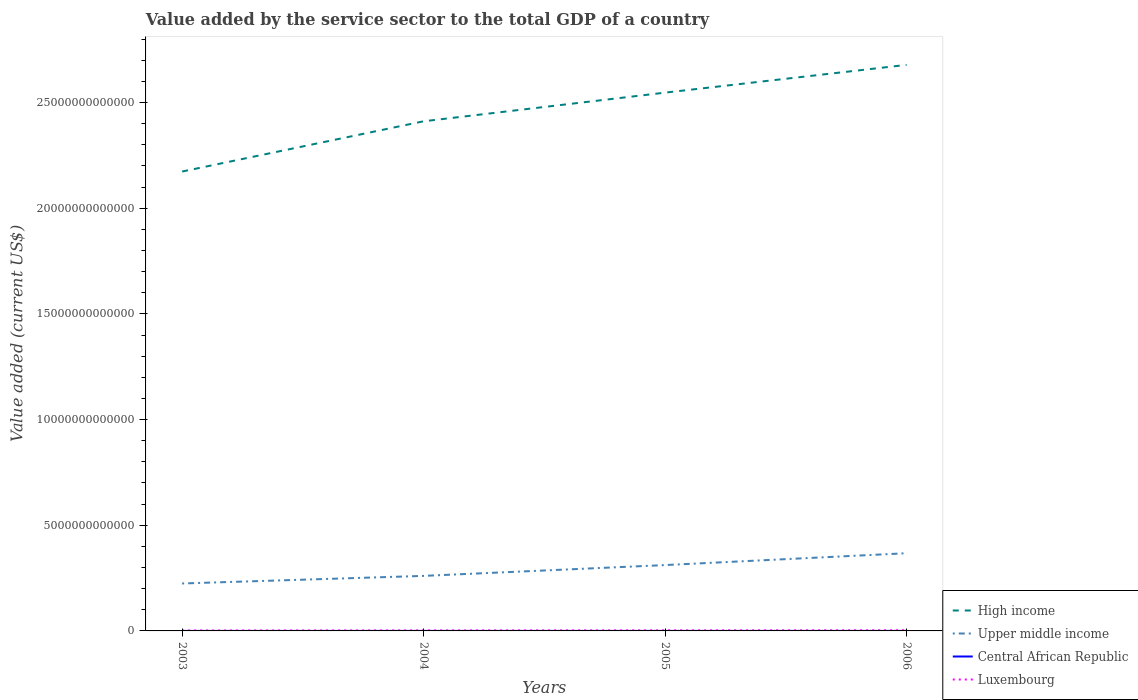How many different coloured lines are there?
Provide a short and direct response. 4. Does the line corresponding to Upper middle income intersect with the line corresponding to Central African Republic?
Offer a very short reply. No. Across all years, what is the maximum value added by the service sector to the total GDP in High income?
Ensure brevity in your answer.  2.17e+13. In which year was the value added by the service sector to the total GDP in Central African Republic maximum?
Keep it short and to the point. 2003. What is the total value added by the service sector to the total GDP in High income in the graph?
Your answer should be very brief. -2.67e+12. What is the difference between the highest and the second highest value added by the service sector to the total GDP in Upper middle income?
Make the answer very short. 1.43e+12. What is the difference between the highest and the lowest value added by the service sector to the total GDP in High income?
Offer a very short reply. 2. What is the difference between two consecutive major ticks on the Y-axis?
Your answer should be very brief. 5.00e+12. Does the graph contain any zero values?
Offer a terse response. No. Does the graph contain grids?
Your answer should be compact. No. How many legend labels are there?
Provide a short and direct response. 4. What is the title of the graph?
Give a very brief answer. Value added by the service sector to the total GDP of a country. Does "Tunisia" appear as one of the legend labels in the graph?
Your answer should be compact. No. What is the label or title of the Y-axis?
Keep it short and to the point. Value added (current US$). What is the Value added (current US$) of High income in 2003?
Provide a succinct answer. 2.17e+13. What is the Value added (current US$) of Upper middle income in 2003?
Provide a short and direct response. 2.24e+12. What is the Value added (current US$) of Central African Republic in 2003?
Provide a short and direct response. 3.19e+08. What is the Value added (current US$) of Luxembourg in 2003?
Provide a short and direct response. 2.13e+1. What is the Value added (current US$) of High income in 2004?
Provide a succinct answer. 2.41e+13. What is the Value added (current US$) in Upper middle income in 2004?
Keep it short and to the point. 2.60e+12. What is the Value added (current US$) in Central African Republic in 2004?
Keep it short and to the point. 3.62e+08. What is the Value added (current US$) in Luxembourg in 2004?
Ensure brevity in your answer.  2.50e+1. What is the Value added (current US$) of High income in 2005?
Your answer should be very brief. 2.55e+13. What is the Value added (current US$) of Upper middle income in 2005?
Your answer should be very brief. 3.12e+12. What is the Value added (current US$) of Central African Republic in 2005?
Your response must be concise. 3.91e+08. What is the Value added (current US$) in Luxembourg in 2005?
Your response must be concise. 2.74e+1. What is the Value added (current US$) in High income in 2006?
Provide a short and direct response. 2.68e+13. What is the Value added (current US$) in Upper middle income in 2006?
Offer a very short reply. 3.68e+12. What is the Value added (current US$) in Central African Republic in 2006?
Your answer should be very brief. 4.25e+08. What is the Value added (current US$) of Luxembourg in 2006?
Keep it short and to the point. 3.18e+1. Across all years, what is the maximum Value added (current US$) in High income?
Keep it short and to the point. 2.68e+13. Across all years, what is the maximum Value added (current US$) of Upper middle income?
Your answer should be compact. 3.68e+12. Across all years, what is the maximum Value added (current US$) in Central African Republic?
Offer a very short reply. 4.25e+08. Across all years, what is the maximum Value added (current US$) of Luxembourg?
Give a very brief answer. 3.18e+1. Across all years, what is the minimum Value added (current US$) in High income?
Your response must be concise. 2.17e+13. Across all years, what is the minimum Value added (current US$) of Upper middle income?
Your response must be concise. 2.24e+12. Across all years, what is the minimum Value added (current US$) in Central African Republic?
Your answer should be very brief. 3.19e+08. Across all years, what is the minimum Value added (current US$) in Luxembourg?
Make the answer very short. 2.13e+1. What is the total Value added (current US$) in High income in the graph?
Offer a terse response. 9.81e+13. What is the total Value added (current US$) in Upper middle income in the graph?
Your response must be concise. 1.16e+13. What is the total Value added (current US$) in Central African Republic in the graph?
Provide a short and direct response. 1.50e+09. What is the total Value added (current US$) in Luxembourg in the graph?
Offer a very short reply. 1.05e+11. What is the difference between the Value added (current US$) in High income in 2003 and that in 2004?
Provide a short and direct response. -2.38e+12. What is the difference between the Value added (current US$) in Upper middle income in 2003 and that in 2004?
Give a very brief answer. -3.60e+11. What is the difference between the Value added (current US$) in Central African Republic in 2003 and that in 2004?
Make the answer very short. -4.29e+07. What is the difference between the Value added (current US$) in Luxembourg in 2003 and that in 2004?
Offer a very short reply. -3.70e+09. What is the difference between the Value added (current US$) of High income in 2003 and that in 2005?
Ensure brevity in your answer.  -3.73e+12. What is the difference between the Value added (current US$) of Upper middle income in 2003 and that in 2005?
Ensure brevity in your answer.  -8.71e+11. What is the difference between the Value added (current US$) of Central African Republic in 2003 and that in 2005?
Your answer should be very brief. -7.21e+07. What is the difference between the Value added (current US$) of Luxembourg in 2003 and that in 2005?
Make the answer very short. -6.07e+09. What is the difference between the Value added (current US$) of High income in 2003 and that in 2006?
Give a very brief answer. -5.05e+12. What is the difference between the Value added (current US$) in Upper middle income in 2003 and that in 2006?
Offer a terse response. -1.43e+12. What is the difference between the Value added (current US$) in Central African Republic in 2003 and that in 2006?
Provide a succinct answer. -1.06e+08. What is the difference between the Value added (current US$) in Luxembourg in 2003 and that in 2006?
Provide a succinct answer. -1.05e+1. What is the difference between the Value added (current US$) of High income in 2004 and that in 2005?
Provide a short and direct response. -1.36e+12. What is the difference between the Value added (current US$) of Upper middle income in 2004 and that in 2005?
Offer a very short reply. -5.12e+11. What is the difference between the Value added (current US$) in Central African Republic in 2004 and that in 2005?
Keep it short and to the point. -2.93e+07. What is the difference between the Value added (current US$) in Luxembourg in 2004 and that in 2005?
Offer a very short reply. -2.37e+09. What is the difference between the Value added (current US$) of High income in 2004 and that in 2006?
Your answer should be very brief. -2.67e+12. What is the difference between the Value added (current US$) of Upper middle income in 2004 and that in 2006?
Provide a short and direct response. -1.07e+12. What is the difference between the Value added (current US$) of Central African Republic in 2004 and that in 2006?
Provide a short and direct response. -6.30e+07. What is the difference between the Value added (current US$) of Luxembourg in 2004 and that in 2006?
Ensure brevity in your answer.  -6.82e+09. What is the difference between the Value added (current US$) in High income in 2005 and that in 2006?
Provide a succinct answer. -1.31e+12. What is the difference between the Value added (current US$) in Upper middle income in 2005 and that in 2006?
Provide a short and direct response. -5.61e+11. What is the difference between the Value added (current US$) in Central African Republic in 2005 and that in 2006?
Make the answer very short. -3.38e+07. What is the difference between the Value added (current US$) of Luxembourg in 2005 and that in 2006?
Keep it short and to the point. -4.45e+09. What is the difference between the Value added (current US$) of High income in 2003 and the Value added (current US$) of Upper middle income in 2004?
Offer a terse response. 1.91e+13. What is the difference between the Value added (current US$) of High income in 2003 and the Value added (current US$) of Central African Republic in 2004?
Your answer should be very brief. 2.17e+13. What is the difference between the Value added (current US$) in High income in 2003 and the Value added (current US$) in Luxembourg in 2004?
Provide a succinct answer. 2.17e+13. What is the difference between the Value added (current US$) of Upper middle income in 2003 and the Value added (current US$) of Central African Republic in 2004?
Keep it short and to the point. 2.24e+12. What is the difference between the Value added (current US$) in Upper middle income in 2003 and the Value added (current US$) in Luxembourg in 2004?
Make the answer very short. 2.22e+12. What is the difference between the Value added (current US$) in Central African Republic in 2003 and the Value added (current US$) in Luxembourg in 2004?
Provide a short and direct response. -2.47e+1. What is the difference between the Value added (current US$) of High income in 2003 and the Value added (current US$) of Upper middle income in 2005?
Your answer should be compact. 1.86e+13. What is the difference between the Value added (current US$) of High income in 2003 and the Value added (current US$) of Central African Republic in 2005?
Your answer should be very brief. 2.17e+13. What is the difference between the Value added (current US$) of High income in 2003 and the Value added (current US$) of Luxembourg in 2005?
Offer a very short reply. 2.17e+13. What is the difference between the Value added (current US$) of Upper middle income in 2003 and the Value added (current US$) of Central African Republic in 2005?
Provide a succinct answer. 2.24e+12. What is the difference between the Value added (current US$) in Upper middle income in 2003 and the Value added (current US$) in Luxembourg in 2005?
Provide a short and direct response. 2.22e+12. What is the difference between the Value added (current US$) in Central African Republic in 2003 and the Value added (current US$) in Luxembourg in 2005?
Your answer should be very brief. -2.70e+1. What is the difference between the Value added (current US$) in High income in 2003 and the Value added (current US$) in Upper middle income in 2006?
Offer a terse response. 1.81e+13. What is the difference between the Value added (current US$) of High income in 2003 and the Value added (current US$) of Central African Republic in 2006?
Provide a succinct answer. 2.17e+13. What is the difference between the Value added (current US$) of High income in 2003 and the Value added (current US$) of Luxembourg in 2006?
Offer a terse response. 2.17e+13. What is the difference between the Value added (current US$) of Upper middle income in 2003 and the Value added (current US$) of Central African Republic in 2006?
Offer a terse response. 2.24e+12. What is the difference between the Value added (current US$) of Upper middle income in 2003 and the Value added (current US$) of Luxembourg in 2006?
Ensure brevity in your answer.  2.21e+12. What is the difference between the Value added (current US$) of Central African Republic in 2003 and the Value added (current US$) of Luxembourg in 2006?
Provide a succinct answer. -3.15e+1. What is the difference between the Value added (current US$) of High income in 2004 and the Value added (current US$) of Upper middle income in 2005?
Ensure brevity in your answer.  2.10e+13. What is the difference between the Value added (current US$) in High income in 2004 and the Value added (current US$) in Central African Republic in 2005?
Ensure brevity in your answer.  2.41e+13. What is the difference between the Value added (current US$) of High income in 2004 and the Value added (current US$) of Luxembourg in 2005?
Your response must be concise. 2.41e+13. What is the difference between the Value added (current US$) of Upper middle income in 2004 and the Value added (current US$) of Central African Republic in 2005?
Your answer should be very brief. 2.60e+12. What is the difference between the Value added (current US$) of Upper middle income in 2004 and the Value added (current US$) of Luxembourg in 2005?
Give a very brief answer. 2.58e+12. What is the difference between the Value added (current US$) of Central African Republic in 2004 and the Value added (current US$) of Luxembourg in 2005?
Your answer should be very brief. -2.70e+1. What is the difference between the Value added (current US$) in High income in 2004 and the Value added (current US$) in Upper middle income in 2006?
Make the answer very short. 2.04e+13. What is the difference between the Value added (current US$) in High income in 2004 and the Value added (current US$) in Central African Republic in 2006?
Your response must be concise. 2.41e+13. What is the difference between the Value added (current US$) of High income in 2004 and the Value added (current US$) of Luxembourg in 2006?
Keep it short and to the point. 2.41e+13. What is the difference between the Value added (current US$) of Upper middle income in 2004 and the Value added (current US$) of Central African Republic in 2006?
Provide a short and direct response. 2.60e+12. What is the difference between the Value added (current US$) in Upper middle income in 2004 and the Value added (current US$) in Luxembourg in 2006?
Make the answer very short. 2.57e+12. What is the difference between the Value added (current US$) of Central African Republic in 2004 and the Value added (current US$) of Luxembourg in 2006?
Your answer should be very brief. -3.15e+1. What is the difference between the Value added (current US$) of High income in 2005 and the Value added (current US$) of Upper middle income in 2006?
Make the answer very short. 2.18e+13. What is the difference between the Value added (current US$) in High income in 2005 and the Value added (current US$) in Central African Republic in 2006?
Make the answer very short. 2.55e+13. What is the difference between the Value added (current US$) in High income in 2005 and the Value added (current US$) in Luxembourg in 2006?
Ensure brevity in your answer.  2.54e+13. What is the difference between the Value added (current US$) of Upper middle income in 2005 and the Value added (current US$) of Central African Republic in 2006?
Keep it short and to the point. 3.12e+12. What is the difference between the Value added (current US$) in Upper middle income in 2005 and the Value added (current US$) in Luxembourg in 2006?
Offer a terse response. 3.08e+12. What is the difference between the Value added (current US$) in Central African Republic in 2005 and the Value added (current US$) in Luxembourg in 2006?
Your response must be concise. -3.14e+1. What is the average Value added (current US$) of High income per year?
Provide a succinct answer. 2.45e+13. What is the average Value added (current US$) of Upper middle income per year?
Your answer should be compact. 2.91e+12. What is the average Value added (current US$) in Central African Republic per year?
Your answer should be very brief. 3.74e+08. What is the average Value added (current US$) of Luxembourg per year?
Keep it short and to the point. 2.64e+1. In the year 2003, what is the difference between the Value added (current US$) of High income and Value added (current US$) of Upper middle income?
Your response must be concise. 1.95e+13. In the year 2003, what is the difference between the Value added (current US$) of High income and Value added (current US$) of Central African Republic?
Your answer should be very brief. 2.17e+13. In the year 2003, what is the difference between the Value added (current US$) of High income and Value added (current US$) of Luxembourg?
Your response must be concise. 2.17e+13. In the year 2003, what is the difference between the Value added (current US$) in Upper middle income and Value added (current US$) in Central African Republic?
Give a very brief answer. 2.24e+12. In the year 2003, what is the difference between the Value added (current US$) of Upper middle income and Value added (current US$) of Luxembourg?
Your answer should be very brief. 2.22e+12. In the year 2003, what is the difference between the Value added (current US$) of Central African Republic and Value added (current US$) of Luxembourg?
Keep it short and to the point. -2.10e+1. In the year 2004, what is the difference between the Value added (current US$) of High income and Value added (current US$) of Upper middle income?
Provide a succinct answer. 2.15e+13. In the year 2004, what is the difference between the Value added (current US$) of High income and Value added (current US$) of Central African Republic?
Your answer should be compact. 2.41e+13. In the year 2004, what is the difference between the Value added (current US$) in High income and Value added (current US$) in Luxembourg?
Give a very brief answer. 2.41e+13. In the year 2004, what is the difference between the Value added (current US$) in Upper middle income and Value added (current US$) in Central African Republic?
Give a very brief answer. 2.60e+12. In the year 2004, what is the difference between the Value added (current US$) in Upper middle income and Value added (current US$) in Luxembourg?
Provide a succinct answer. 2.58e+12. In the year 2004, what is the difference between the Value added (current US$) in Central African Republic and Value added (current US$) in Luxembourg?
Provide a short and direct response. -2.46e+1. In the year 2005, what is the difference between the Value added (current US$) of High income and Value added (current US$) of Upper middle income?
Provide a succinct answer. 2.24e+13. In the year 2005, what is the difference between the Value added (current US$) in High income and Value added (current US$) in Central African Republic?
Make the answer very short. 2.55e+13. In the year 2005, what is the difference between the Value added (current US$) in High income and Value added (current US$) in Luxembourg?
Provide a short and direct response. 2.54e+13. In the year 2005, what is the difference between the Value added (current US$) of Upper middle income and Value added (current US$) of Central African Republic?
Provide a succinct answer. 3.12e+12. In the year 2005, what is the difference between the Value added (current US$) of Upper middle income and Value added (current US$) of Luxembourg?
Your answer should be very brief. 3.09e+12. In the year 2005, what is the difference between the Value added (current US$) in Central African Republic and Value added (current US$) in Luxembourg?
Give a very brief answer. -2.70e+1. In the year 2006, what is the difference between the Value added (current US$) in High income and Value added (current US$) in Upper middle income?
Keep it short and to the point. 2.31e+13. In the year 2006, what is the difference between the Value added (current US$) of High income and Value added (current US$) of Central African Republic?
Your answer should be very brief. 2.68e+13. In the year 2006, what is the difference between the Value added (current US$) of High income and Value added (current US$) of Luxembourg?
Keep it short and to the point. 2.68e+13. In the year 2006, what is the difference between the Value added (current US$) in Upper middle income and Value added (current US$) in Central African Republic?
Your response must be concise. 3.68e+12. In the year 2006, what is the difference between the Value added (current US$) of Upper middle income and Value added (current US$) of Luxembourg?
Ensure brevity in your answer.  3.65e+12. In the year 2006, what is the difference between the Value added (current US$) in Central African Republic and Value added (current US$) in Luxembourg?
Provide a short and direct response. -3.14e+1. What is the ratio of the Value added (current US$) of High income in 2003 to that in 2004?
Your answer should be very brief. 0.9. What is the ratio of the Value added (current US$) of Upper middle income in 2003 to that in 2004?
Provide a succinct answer. 0.86. What is the ratio of the Value added (current US$) in Central African Republic in 2003 to that in 2004?
Your response must be concise. 0.88. What is the ratio of the Value added (current US$) of Luxembourg in 2003 to that in 2004?
Your response must be concise. 0.85. What is the ratio of the Value added (current US$) of High income in 2003 to that in 2005?
Make the answer very short. 0.85. What is the ratio of the Value added (current US$) of Upper middle income in 2003 to that in 2005?
Ensure brevity in your answer.  0.72. What is the ratio of the Value added (current US$) in Central African Republic in 2003 to that in 2005?
Keep it short and to the point. 0.82. What is the ratio of the Value added (current US$) of Luxembourg in 2003 to that in 2005?
Your answer should be very brief. 0.78. What is the ratio of the Value added (current US$) of High income in 2003 to that in 2006?
Your answer should be very brief. 0.81. What is the ratio of the Value added (current US$) of Upper middle income in 2003 to that in 2006?
Offer a very short reply. 0.61. What is the ratio of the Value added (current US$) in Central African Republic in 2003 to that in 2006?
Give a very brief answer. 0.75. What is the ratio of the Value added (current US$) in Luxembourg in 2003 to that in 2006?
Offer a terse response. 0.67. What is the ratio of the Value added (current US$) of High income in 2004 to that in 2005?
Offer a very short reply. 0.95. What is the ratio of the Value added (current US$) in Upper middle income in 2004 to that in 2005?
Provide a short and direct response. 0.84. What is the ratio of the Value added (current US$) of Central African Republic in 2004 to that in 2005?
Provide a succinct answer. 0.93. What is the ratio of the Value added (current US$) in Luxembourg in 2004 to that in 2005?
Your response must be concise. 0.91. What is the ratio of the Value added (current US$) of High income in 2004 to that in 2006?
Offer a very short reply. 0.9. What is the ratio of the Value added (current US$) in Upper middle income in 2004 to that in 2006?
Provide a succinct answer. 0.71. What is the ratio of the Value added (current US$) of Central African Republic in 2004 to that in 2006?
Give a very brief answer. 0.85. What is the ratio of the Value added (current US$) of Luxembourg in 2004 to that in 2006?
Provide a succinct answer. 0.79. What is the ratio of the Value added (current US$) in High income in 2005 to that in 2006?
Ensure brevity in your answer.  0.95. What is the ratio of the Value added (current US$) in Upper middle income in 2005 to that in 2006?
Your answer should be compact. 0.85. What is the ratio of the Value added (current US$) in Central African Republic in 2005 to that in 2006?
Ensure brevity in your answer.  0.92. What is the ratio of the Value added (current US$) in Luxembourg in 2005 to that in 2006?
Your answer should be very brief. 0.86. What is the difference between the highest and the second highest Value added (current US$) of High income?
Give a very brief answer. 1.31e+12. What is the difference between the highest and the second highest Value added (current US$) in Upper middle income?
Provide a short and direct response. 5.61e+11. What is the difference between the highest and the second highest Value added (current US$) of Central African Republic?
Keep it short and to the point. 3.38e+07. What is the difference between the highest and the second highest Value added (current US$) in Luxembourg?
Your answer should be very brief. 4.45e+09. What is the difference between the highest and the lowest Value added (current US$) of High income?
Provide a short and direct response. 5.05e+12. What is the difference between the highest and the lowest Value added (current US$) of Upper middle income?
Keep it short and to the point. 1.43e+12. What is the difference between the highest and the lowest Value added (current US$) in Central African Republic?
Provide a succinct answer. 1.06e+08. What is the difference between the highest and the lowest Value added (current US$) of Luxembourg?
Keep it short and to the point. 1.05e+1. 